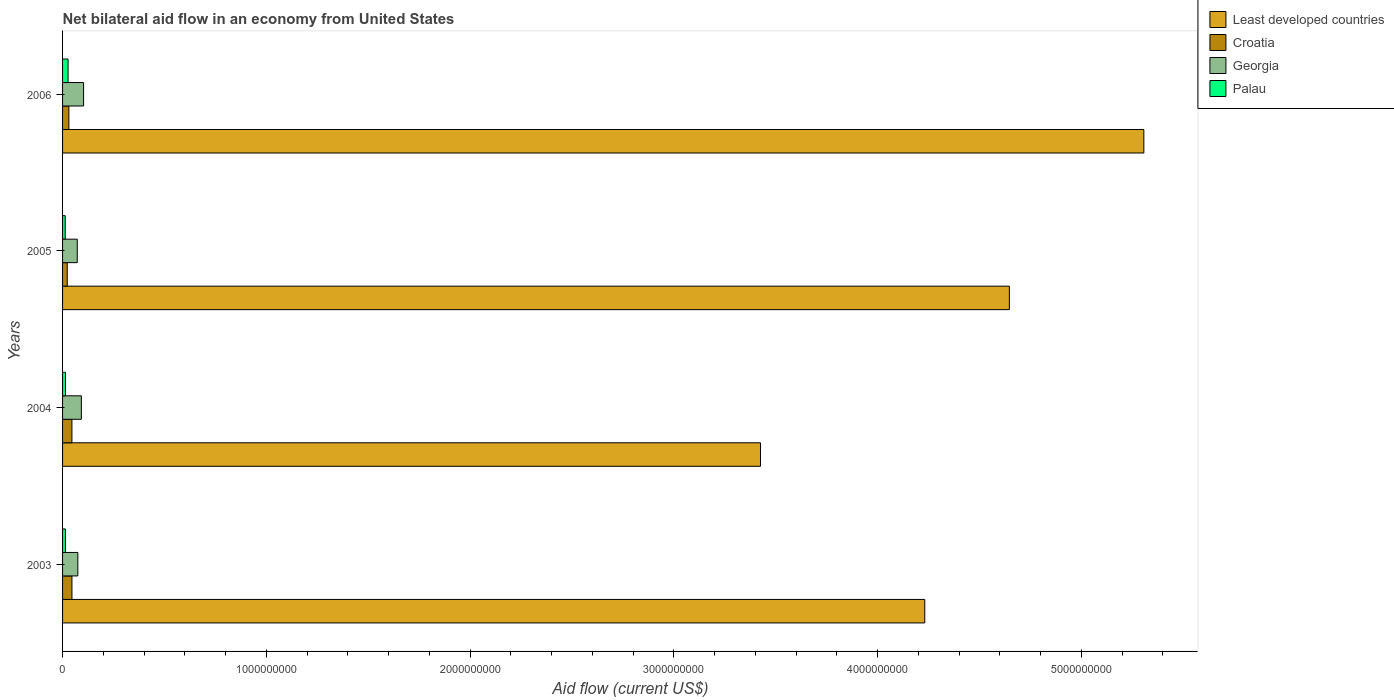How many groups of bars are there?
Offer a terse response. 4. Are the number of bars per tick equal to the number of legend labels?
Give a very brief answer. Yes. Are the number of bars on each tick of the Y-axis equal?
Make the answer very short. Yes. How many bars are there on the 3rd tick from the bottom?
Your answer should be very brief. 4. What is the net bilateral aid flow in Croatia in 2004?
Provide a short and direct response. 4.59e+07. Across all years, what is the maximum net bilateral aid flow in Least developed countries?
Keep it short and to the point. 5.31e+09. Across all years, what is the minimum net bilateral aid flow in Croatia?
Provide a short and direct response. 2.29e+07. In which year was the net bilateral aid flow in Palau maximum?
Offer a terse response. 2006. In which year was the net bilateral aid flow in Croatia minimum?
Your answer should be compact. 2005. What is the total net bilateral aid flow in Least developed countries in the graph?
Provide a short and direct response. 1.76e+1. What is the difference between the net bilateral aid flow in Palau in 2003 and that in 2005?
Ensure brevity in your answer.  9.00e+05. What is the difference between the net bilateral aid flow in Least developed countries in 2005 and the net bilateral aid flow in Palau in 2003?
Ensure brevity in your answer.  4.63e+09. What is the average net bilateral aid flow in Georgia per year?
Your answer should be compact. 8.56e+07. In the year 2005, what is the difference between the net bilateral aid flow in Croatia and net bilateral aid flow in Least developed countries?
Your response must be concise. -4.62e+09. In how many years, is the net bilateral aid flow in Palau greater than 4600000000 US$?
Offer a terse response. 0. What is the ratio of the net bilateral aid flow in Palau in 2003 to that in 2004?
Provide a succinct answer. 0.99. Is the difference between the net bilateral aid flow in Croatia in 2003 and 2005 greater than the difference between the net bilateral aid flow in Least developed countries in 2003 and 2005?
Offer a very short reply. Yes. What is the difference between the highest and the second highest net bilateral aid flow in Palau?
Keep it short and to the point. 1.29e+07. What is the difference between the highest and the lowest net bilateral aid flow in Croatia?
Give a very brief answer. 2.31e+07. In how many years, is the net bilateral aid flow in Palau greater than the average net bilateral aid flow in Palau taken over all years?
Offer a very short reply. 1. Is the sum of the net bilateral aid flow in Croatia in 2003 and 2004 greater than the maximum net bilateral aid flow in Georgia across all years?
Offer a terse response. No. What does the 1st bar from the top in 2003 represents?
Keep it short and to the point. Palau. What does the 3rd bar from the bottom in 2005 represents?
Make the answer very short. Georgia. How many bars are there?
Offer a very short reply. 16. Are all the bars in the graph horizontal?
Offer a terse response. Yes. Are the values on the major ticks of X-axis written in scientific E-notation?
Provide a short and direct response. No. Does the graph contain any zero values?
Offer a terse response. No. Does the graph contain grids?
Give a very brief answer. No. How many legend labels are there?
Ensure brevity in your answer.  4. What is the title of the graph?
Ensure brevity in your answer.  Net bilateral aid flow in an economy from United States. What is the label or title of the X-axis?
Your answer should be very brief. Aid flow (current US$). What is the label or title of the Y-axis?
Keep it short and to the point. Years. What is the Aid flow (current US$) of Least developed countries in 2003?
Provide a succinct answer. 4.23e+09. What is the Aid flow (current US$) in Croatia in 2003?
Your response must be concise. 4.60e+07. What is the Aid flow (current US$) in Georgia in 2003?
Offer a very short reply. 7.50e+07. What is the Aid flow (current US$) in Palau in 2003?
Offer a very short reply. 1.40e+07. What is the Aid flow (current US$) in Least developed countries in 2004?
Keep it short and to the point. 3.43e+09. What is the Aid flow (current US$) in Croatia in 2004?
Your answer should be very brief. 4.59e+07. What is the Aid flow (current US$) in Georgia in 2004?
Provide a succinct answer. 9.23e+07. What is the Aid flow (current US$) in Palau in 2004?
Offer a very short reply. 1.41e+07. What is the Aid flow (current US$) in Least developed countries in 2005?
Your answer should be compact. 4.65e+09. What is the Aid flow (current US$) in Croatia in 2005?
Provide a succinct answer. 2.29e+07. What is the Aid flow (current US$) in Georgia in 2005?
Keep it short and to the point. 7.20e+07. What is the Aid flow (current US$) in Palau in 2005?
Make the answer very short. 1.31e+07. What is the Aid flow (current US$) of Least developed countries in 2006?
Offer a terse response. 5.31e+09. What is the Aid flow (current US$) of Croatia in 2006?
Your answer should be compact. 3.09e+07. What is the Aid flow (current US$) in Georgia in 2006?
Offer a terse response. 1.03e+08. What is the Aid flow (current US$) in Palau in 2006?
Provide a short and direct response. 2.70e+07. Across all years, what is the maximum Aid flow (current US$) in Least developed countries?
Keep it short and to the point. 5.31e+09. Across all years, what is the maximum Aid flow (current US$) of Croatia?
Keep it short and to the point. 4.60e+07. Across all years, what is the maximum Aid flow (current US$) of Georgia?
Your answer should be compact. 1.03e+08. Across all years, what is the maximum Aid flow (current US$) of Palau?
Offer a very short reply. 2.70e+07. Across all years, what is the minimum Aid flow (current US$) in Least developed countries?
Give a very brief answer. 3.43e+09. Across all years, what is the minimum Aid flow (current US$) in Croatia?
Make the answer very short. 2.29e+07. Across all years, what is the minimum Aid flow (current US$) of Georgia?
Make the answer very short. 7.20e+07. Across all years, what is the minimum Aid flow (current US$) in Palau?
Your answer should be compact. 1.31e+07. What is the total Aid flow (current US$) of Least developed countries in the graph?
Offer a very short reply. 1.76e+1. What is the total Aid flow (current US$) of Croatia in the graph?
Make the answer very short. 1.46e+08. What is the total Aid flow (current US$) of Georgia in the graph?
Give a very brief answer. 3.42e+08. What is the total Aid flow (current US$) of Palau in the graph?
Your response must be concise. 6.82e+07. What is the difference between the Aid flow (current US$) of Least developed countries in 2003 and that in 2004?
Offer a terse response. 8.06e+08. What is the difference between the Aid flow (current US$) of Georgia in 2003 and that in 2004?
Ensure brevity in your answer.  -1.73e+07. What is the difference between the Aid flow (current US$) of Least developed countries in 2003 and that in 2005?
Your answer should be very brief. -4.15e+08. What is the difference between the Aid flow (current US$) in Croatia in 2003 and that in 2005?
Offer a very short reply. 2.31e+07. What is the difference between the Aid flow (current US$) of Georgia in 2003 and that in 2005?
Offer a very short reply. 2.90e+06. What is the difference between the Aid flow (current US$) of Palau in 2003 and that in 2005?
Your answer should be very brief. 9.00e+05. What is the difference between the Aid flow (current US$) of Least developed countries in 2003 and that in 2006?
Provide a short and direct response. -1.08e+09. What is the difference between the Aid flow (current US$) of Croatia in 2003 and that in 2006?
Your answer should be compact. 1.50e+07. What is the difference between the Aid flow (current US$) in Georgia in 2003 and that in 2006?
Your answer should be very brief. -2.83e+07. What is the difference between the Aid flow (current US$) in Palau in 2003 and that in 2006?
Your answer should be very brief. -1.30e+07. What is the difference between the Aid flow (current US$) of Least developed countries in 2004 and that in 2005?
Your answer should be very brief. -1.22e+09. What is the difference between the Aid flow (current US$) in Croatia in 2004 and that in 2005?
Keep it short and to the point. 2.30e+07. What is the difference between the Aid flow (current US$) in Georgia in 2004 and that in 2005?
Make the answer very short. 2.02e+07. What is the difference between the Aid flow (current US$) of Palau in 2004 and that in 2005?
Ensure brevity in your answer.  1.04e+06. What is the difference between the Aid flow (current US$) in Least developed countries in 2004 and that in 2006?
Offer a terse response. -1.88e+09. What is the difference between the Aid flow (current US$) of Croatia in 2004 and that in 2006?
Your answer should be very brief. 1.50e+07. What is the difference between the Aid flow (current US$) of Georgia in 2004 and that in 2006?
Keep it short and to the point. -1.10e+07. What is the difference between the Aid flow (current US$) of Palau in 2004 and that in 2006?
Offer a terse response. -1.29e+07. What is the difference between the Aid flow (current US$) of Least developed countries in 2005 and that in 2006?
Make the answer very short. -6.60e+08. What is the difference between the Aid flow (current US$) of Croatia in 2005 and that in 2006?
Offer a terse response. -8.05e+06. What is the difference between the Aid flow (current US$) of Georgia in 2005 and that in 2006?
Your response must be concise. -3.12e+07. What is the difference between the Aid flow (current US$) of Palau in 2005 and that in 2006?
Offer a very short reply. -1.39e+07. What is the difference between the Aid flow (current US$) of Least developed countries in 2003 and the Aid flow (current US$) of Croatia in 2004?
Your answer should be compact. 4.19e+09. What is the difference between the Aid flow (current US$) of Least developed countries in 2003 and the Aid flow (current US$) of Georgia in 2004?
Your response must be concise. 4.14e+09. What is the difference between the Aid flow (current US$) in Least developed countries in 2003 and the Aid flow (current US$) in Palau in 2004?
Offer a very short reply. 4.22e+09. What is the difference between the Aid flow (current US$) in Croatia in 2003 and the Aid flow (current US$) in Georgia in 2004?
Keep it short and to the point. -4.63e+07. What is the difference between the Aid flow (current US$) in Croatia in 2003 and the Aid flow (current US$) in Palau in 2004?
Ensure brevity in your answer.  3.18e+07. What is the difference between the Aid flow (current US$) in Georgia in 2003 and the Aid flow (current US$) in Palau in 2004?
Offer a very short reply. 6.08e+07. What is the difference between the Aid flow (current US$) in Least developed countries in 2003 and the Aid flow (current US$) in Croatia in 2005?
Ensure brevity in your answer.  4.21e+09. What is the difference between the Aid flow (current US$) of Least developed countries in 2003 and the Aid flow (current US$) of Georgia in 2005?
Offer a terse response. 4.16e+09. What is the difference between the Aid flow (current US$) in Least developed countries in 2003 and the Aid flow (current US$) in Palau in 2005?
Your response must be concise. 4.22e+09. What is the difference between the Aid flow (current US$) of Croatia in 2003 and the Aid flow (current US$) of Georgia in 2005?
Provide a short and direct response. -2.61e+07. What is the difference between the Aid flow (current US$) of Croatia in 2003 and the Aid flow (current US$) of Palau in 2005?
Make the answer very short. 3.29e+07. What is the difference between the Aid flow (current US$) in Georgia in 2003 and the Aid flow (current US$) in Palau in 2005?
Offer a very short reply. 6.18e+07. What is the difference between the Aid flow (current US$) in Least developed countries in 2003 and the Aid flow (current US$) in Croatia in 2006?
Provide a succinct answer. 4.20e+09. What is the difference between the Aid flow (current US$) of Least developed countries in 2003 and the Aid flow (current US$) of Georgia in 2006?
Keep it short and to the point. 4.13e+09. What is the difference between the Aid flow (current US$) in Least developed countries in 2003 and the Aid flow (current US$) in Palau in 2006?
Provide a succinct answer. 4.20e+09. What is the difference between the Aid flow (current US$) in Croatia in 2003 and the Aid flow (current US$) in Georgia in 2006?
Keep it short and to the point. -5.73e+07. What is the difference between the Aid flow (current US$) of Croatia in 2003 and the Aid flow (current US$) of Palau in 2006?
Keep it short and to the point. 1.90e+07. What is the difference between the Aid flow (current US$) in Georgia in 2003 and the Aid flow (current US$) in Palau in 2006?
Offer a very short reply. 4.80e+07. What is the difference between the Aid flow (current US$) of Least developed countries in 2004 and the Aid flow (current US$) of Croatia in 2005?
Keep it short and to the point. 3.40e+09. What is the difference between the Aid flow (current US$) in Least developed countries in 2004 and the Aid flow (current US$) in Georgia in 2005?
Offer a terse response. 3.35e+09. What is the difference between the Aid flow (current US$) of Least developed countries in 2004 and the Aid flow (current US$) of Palau in 2005?
Give a very brief answer. 3.41e+09. What is the difference between the Aid flow (current US$) in Croatia in 2004 and the Aid flow (current US$) in Georgia in 2005?
Offer a terse response. -2.62e+07. What is the difference between the Aid flow (current US$) of Croatia in 2004 and the Aid flow (current US$) of Palau in 2005?
Give a very brief answer. 3.28e+07. What is the difference between the Aid flow (current US$) in Georgia in 2004 and the Aid flow (current US$) in Palau in 2005?
Your answer should be compact. 7.92e+07. What is the difference between the Aid flow (current US$) of Least developed countries in 2004 and the Aid flow (current US$) of Croatia in 2006?
Keep it short and to the point. 3.39e+09. What is the difference between the Aid flow (current US$) in Least developed countries in 2004 and the Aid flow (current US$) in Georgia in 2006?
Give a very brief answer. 3.32e+09. What is the difference between the Aid flow (current US$) of Least developed countries in 2004 and the Aid flow (current US$) of Palau in 2006?
Your answer should be very brief. 3.40e+09. What is the difference between the Aid flow (current US$) of Croatia in 2004 and the Aid flow (current US$) of Georgia in 2006?
Make the answer very short. -5.73e+07. What is the difference between the Aid flow (current US$) in Croatia in 2004 and the Aid flow (current US$) in Palau in 2006?
Give a very brief answer. 1.89e+07. What is the difference between the Aid flow (current US$) in Georgia in 2004 and the Aid flow (current US$) in Palau in 2006?
Offer a terse response. 6.53e+07. What is the difference between the Aid flow (current US$) of Least developed countries in 2005 and the Aid flow (current US$) of Croatia in 2006?
Offer a very short reply. 4.62e+09. What is the difference between the Aid flow (current US$) in Least developed countries in 2005 and the Aid flow (current US$) in Georgia in 2006?
Give a very brief answer. 4.54e+09. What is the difference between the Aid flow (current US$) of Least developed countries in 2005 and the Aid flow (current US$) of Palau in 2006?
Your answer should be compact. 4.62e+09. What is the difference between the Aid flow (current US$) of Croatia in 2005 and the Aid flow (current US$) of Georgia in 2006?
Make the answer very short. -8.04e+07. What is the difference between the Aid flow (current US$) of Croatia in 2005 and the Aid flow (current US$) of Palau in 2006?
Provide a succinct answer. -4.11e+06. What is the difference between the Aid flow (current US$) in Georgia in 2005 and the Aid flow (current US$) in Palau in 2006?
Provide a succinct answer. 4.50e+07. What is the average Aid flow (current US$) in Least developed countries per year?
Offer a terse response. 4.40e+09. What is the average Aid flow (current US$) of Croatia per year?
Your answer should be very brief. 3.64e+07. What is the average Aid flow (current US$) of Georgia per year?
Keep it short and to the point. 8.56e+07. What is the average Aid flow (current US$) in Palau per year?
Provide a succinct answer. 1.71e+07. In the year 2003, what is the difference between the Aid flow (current US$) of Least developed countries and Aid flow (current US$) of Croatia?
Your response must be concise. 4.19e+09. In the year 2003, what is the difference between the Aid flow (current US$) in Least developed countries and Aid flow (current US$) in Georgia?
Give a very brief answer. 4.16e+09. In the year 2003, what is the difference between the Aid flow (current US$) in Least developed countries and Aid flow (current US$) in Palau?
Make the answer very short. 4.22e+09. In the year 2003, what is the difference between the Aid flow (current US$) in Croatia and Aid flow (current US$) in Georgia?
Ensure brevity in your answer.  -2.90e+07. In the year 2003, what is the difference between the Aid flow (current US$) of Croatia and Aid flow (current US$) of Palau?
Keep it short and to the point. 3.20e+07. In the year 2003, what is the difference between the Aid flow (current US$) in Georgia and Aid flow (current US$) in Palau?
Your answer should be very brief. 6.10e+07. In the year 2004, what is the difference between the Aid flow (current US$) of Least developed countries and Aid flow (current US$) of Croatia?
Offer a terse response. 3.38e+09. In the year 2004, what is the difference between the Aid flow (current US$) in Least developed countries and Aid flow (current US$) in Georgia?
Ensure brevity in your answer.  3.33e+09. In the year 2004, what is the difference between the Aid flow (current US$) in Least developed countries and Aid flow (current US$) in Palau?
Ensure brevity in your answer.  3.41e+09. In the year 2004, what is the difference between the Aid flow (current US$) in Croatia and Aid flow (current US$) in Georgia?
Keep it short and to the point. -4.64e+07. In the year 2004, what is the difference between the Aid flow (current US$) of Croatia and Aid flow (current US$) of Palau?
Offer a terse response. 3.18e+07. In the year 2004, what is the difference between the Aid flow (current US$) of Georgia and Aid flow (current US$) of Palau?
Keep it short and to the point. 7.81e+07. In the year 2005, what is the difference between the Aid flow (current US$) of Least developed countries and Aid flow (current US$) of Croatia?
Provide a short and direct response. 4.62e+09. In the year 2005, what is the difference between the Aid flow (current US$) of Least developed countries and Aid flow (current US$) of Georgia?
Your answer should be very brief. 4.57e+09. In the year 2005, what is the difference between the Aid flow (current US$) in Least developed countries and Aid flow (current US$) in Palau?
Your answer should be very brief. 4.63e+09. In the year 2005, what is the difference between the Aid flow (current US$) in Croatia and Aid flow (current US$) in Georgia?
Your answer should be very brief. -4.92e+07. In the year 2005, what is the difference between the Aid flow (current US$) in Croatia and Aid flow (current US$) in Palau?
Give a very brief answer. 9.79e+06. In the year 2005, what is the difference between the Aid flow (current US$) of Georgia and Aid flow (current US$) of Palau?
Offer a terse response. 5.90e+07. In the year 2006, what is the difference between the Aid flow (current US$) in Least developed countries and Aid flow (current US$) in Croatia?
Your answer should be compact. 5.28e+09. In the year 2006, what is the difference between the Aid flow (current US$) in Least developed countries and Aid flow (current US$) in Georgia?
Offer a terse response. 5.20e+09. In the year 2006, what is the difference between the Aid flow (current US$) in Least developed countries and Aid flow (current US$) in Palau?
Give a very brief answer. 5.28e+09. In the year 2006, what is the difference between the Aid flow (current US$) of Croatia and Aid flow (current US$) of Georgia?
Provide a short and direct response. -7.23e+07. In the year 2006, what is the difference between the Aid flow (current US$) in Croatia and Aid flow (current US$) in Palau?
Your answer should be very brief. 3.94e+06. In the year 2006, what is the difference between the Aid flow (current US$) in Georgia and Aid flow (current US$) in Palau?
Offer a terse response. 7.62e+07. What is the ratio of the Aid flow (current US$) in Least developed countries in 2003 to that in 2004?
Your answer should be compact. 1.24. What is the ratio of the Aid flow (current US$) of Croatia in 2003 to that in 2004?
Keep it short and to the point. 1. What is the ratio of the Aid flow (current US$) in Georgia in 2003 to that in 2004?
Your answer should be compact. 0.81. What is the ratio of the Aid flow (current US$) of Least developed countries in 2003 to that in 2005?
Your response must be concise. 0.91. What is the ratio of the Aid flow (current US$) in Croatia in 2003 to that in 2005?
Provide a succinct answer. 2.01. What is the ratio of the Aid flow (current US$) in Georgia in 2003 to that in 2005?
Provide a short and direct response. 1.04. What is the ratio of the Aid flow (current US$) of Palau in 2003 to that in 2005?
Your response must be concise. 1.07. What is the ratio of the Aid flow (current US$) in Least developed countries in 2003 to that in 2006?
Offer a terse response. 0.8. What is the ratio of the Aid flow (current US$) in Croatia in 2003 to that in 2006?
Your response must be concise. 1.49. What is the ratio of the Aid flow (current US$) of Georgia in 2003 to that in 2006?
Keep it short and to the point. 0.73. What is the ratio of the Aid flow (current US$) in Palau in 2003 to that in 2006?
Make the answer very short. 0.52. What is the ratio of the Aid flow (current US$) in Least developed countries in 2004 to that in 2005?
Offer a terse response. 0.74. What is the ratio of the Aid flow (current US$) in Croatia in 2004 to that in 2005?
Ensure brevity in your answer.  2.01. What is the ratio of the Aid flow (current US$) in Georgia in 2004 to that in 2005?
Your answer should be very brief. 1.28. What is the ratio of the Aid flow (current US$) in Palau in 2004 to that in 2005?
Your answer should be compact. 1.08. What is the ratio of the Aid flow (current US$) in Least developed countries in 2004 to that in 2006?
Your response must be concise. 0.65. What is the ratio of the Aid flow (current US$) in Croatia in 2004 to that in 2006?
Offer a terse response. 1.48. What is the ratio of the Aid flow (current US$) in Georgia in 2004 to that in 2006?
Ensure brevity in your answer.  0.89. What is the ratio of the Aid flow (current US$) in Palau in 2004 to that in 2006?
Offer a terse response. 0.52. What is the ratio of the Aid flow (current US$) of Least developed countries in 2005 to that in 2006?
Your answer should be very brief. 0.88. What is the ratio of the Aid flow (current US$) in Croatia in 2005 to that in 2006?
Offer a terse response. 0.74. What is the ratio of the Aid flow (current US$) of Georgia in 2005 to that in 2006?
Keep it short and to the point. 0.7. What is the ratio of the Aid flow (current US$) of Palau in 2005 to that in 2006?
Give a very brief answer. 0.49. What is the difference between the highest and the second highest Aid flow (current US$) in Least developed countries?
Your response must be concise. 6.60e+08. What is the difference between the highest and the second highest Aid flow (current US$) in Croatia?
Your response must be concise. 7.00e+04. What is the difference between the highest and the second highest Aid flow (current US$) in Georgia?
Offer a very short reply. 1.10e+07. What is the difference between the highest and the second highest Aid flow (current US$) of Palau?
Offer a terse response. 1.29e+07. What is the difference between the highest and the lowest Aid flow (current US$) of Least developed countries?
Your answer should be very brief. 1.88e+09. What is the difference between the highest and the lowest Aid flow (current US$) of Croatia?
Provide a short and direct response. 2.31e+07. What is the difference between the highest and the lowest Aid flow (current US$) in Georgia?
Offer a terse response. 3.12e+07. What is the difference between the highest and the lowest Aid flow (current US$) in Palau?
Your response must be concise. 1.39e+07. 